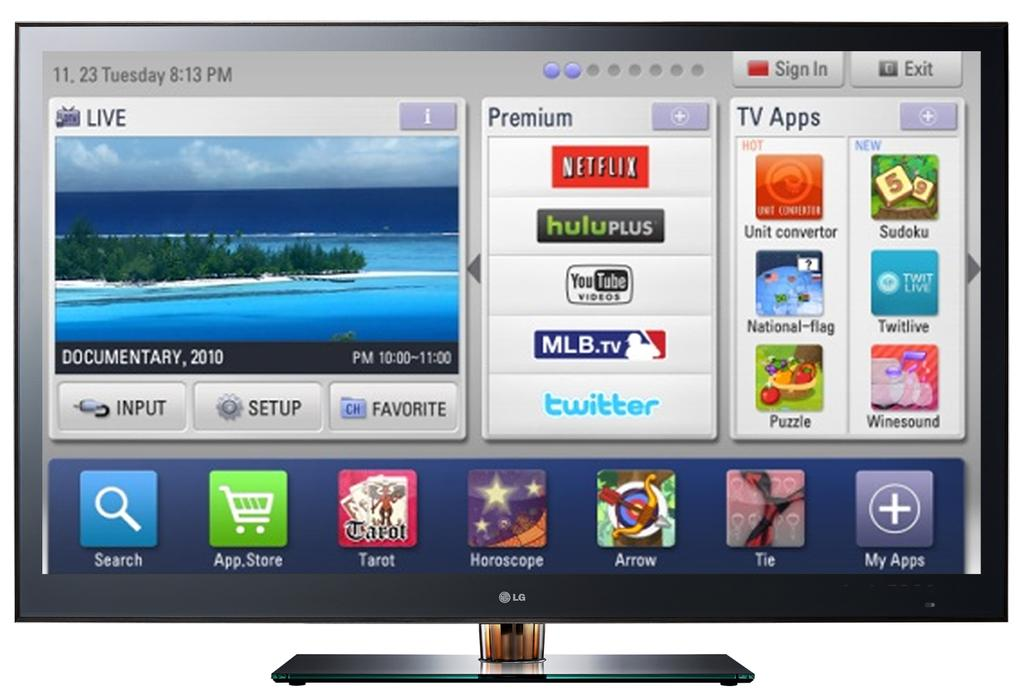Provide a one-sentence caption for the provided image. a computer desktop with icons for netflix hulu, twitter and mlb tv. 